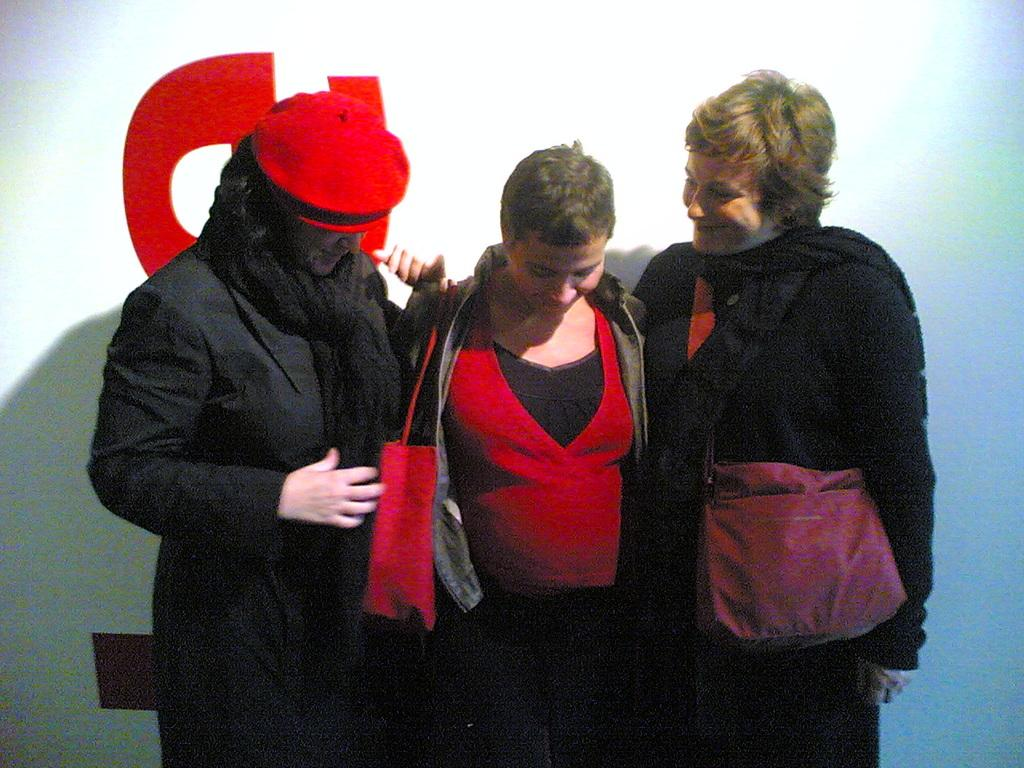How many people are in the image? There are persons in the image, but the exact number is not specified. What color are the dresses worn by the persons in the image? The persons are wearing black colored dresses. What are the persons holding in the image? The persons are holding red colored bags. What colors are present in the background of the image? The background of the image is white and red colored. What type of crayon is being used to draw on the white part of the background? There is no crayon or drawing activity present in the image. How many people are walking towards the feast in the image? There is no feast or walking activity present in the image. 